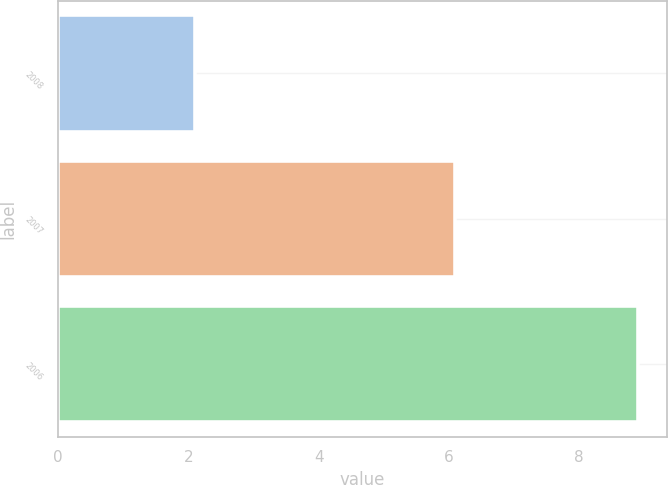<chart> <loc_0><loc_0><loc_500><loc_500><bar_chart><fcel>2008<fcel>2007<fcel>2006<nl><fcel>2.1<fcel>6.1<fcel>8.9<nl></chart> 